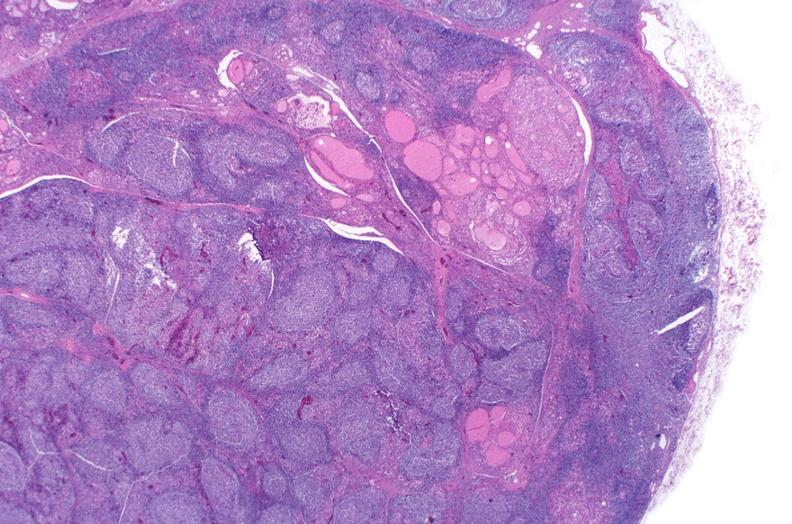s endocrine present?
Answer the question using a single word or phrase. Yes 